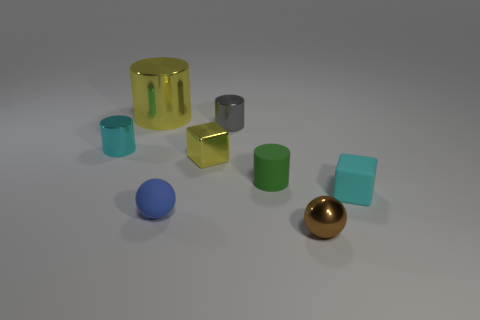Subtract all purple cylinders. Subtract all brown spheres. How many cylinders are left? 4 Add 2 cyan metal things. How many objects exist? 10 Subtract all blocks. How many objects are left? 6 Subtract all small cyan cylinders. Subtract all small yellow things. How many objects are left? 6 Add 2 matte spheres. How many matte spheres are left? 3 Add 4 shiny cylinders. How many shiny cylinders exist? 7 Subtract 1 blue balls. How many objects are left? 7 